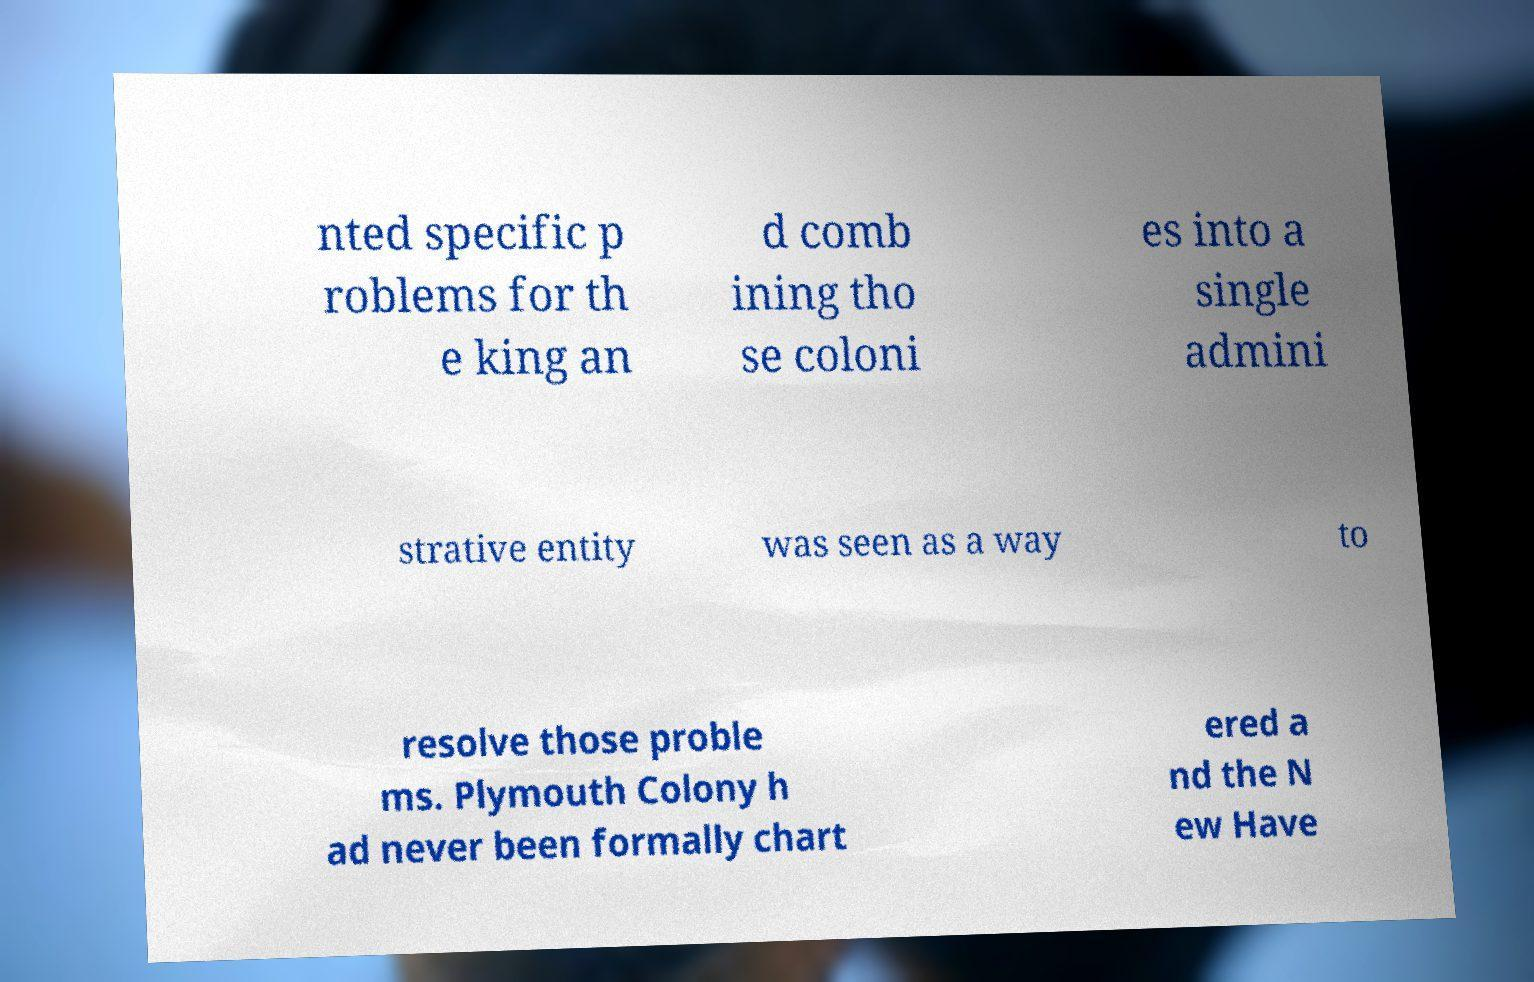There's text embedded in this image that I need extracted. Can you transcribe it verbatim? nted specific p roblems for th e king an d comb ining tho se coloni es into a single admini strative entity was seen as a way to resolve those proble ms. Plymouth Colony h ad never been formally chart ered a nd the N ew Have 